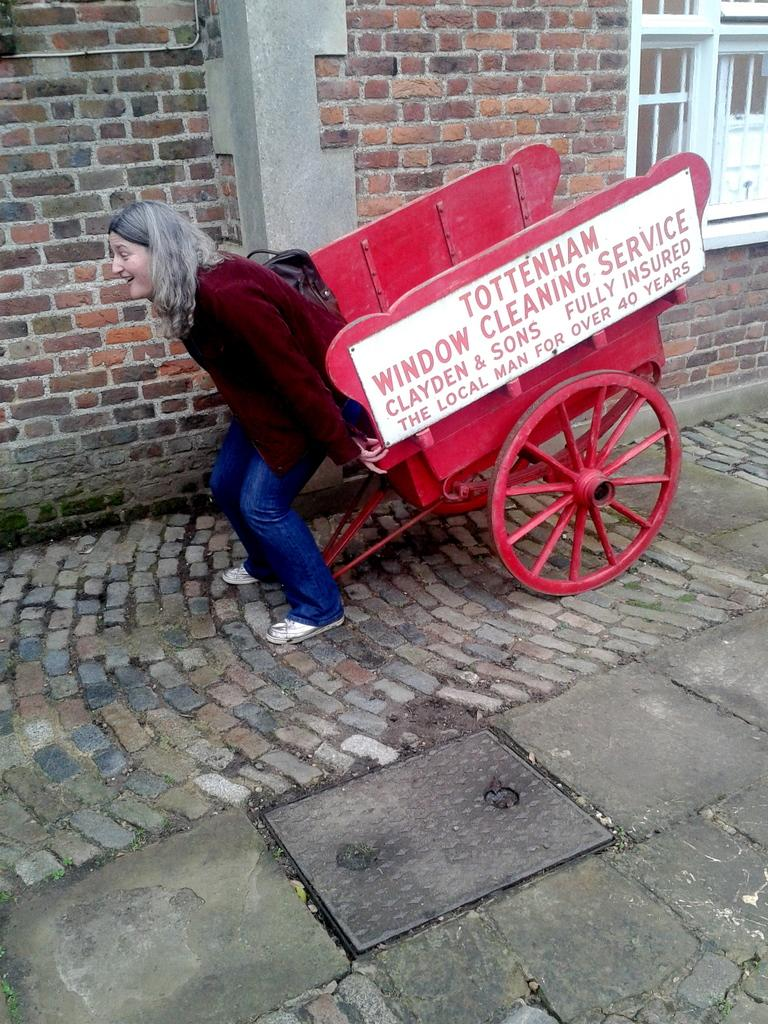What is the woman in the image doing? The woman is standing in the image and holding a carriage. Where is the woman standing? The woman is standing on a footpath. What can be seen in the background of the image? There is a building in the image, and it has a window on the right side. What type of zebra can be seen acting in the waste in the image? There is no zebra present in the image, and it does not depict any waste or acting. 